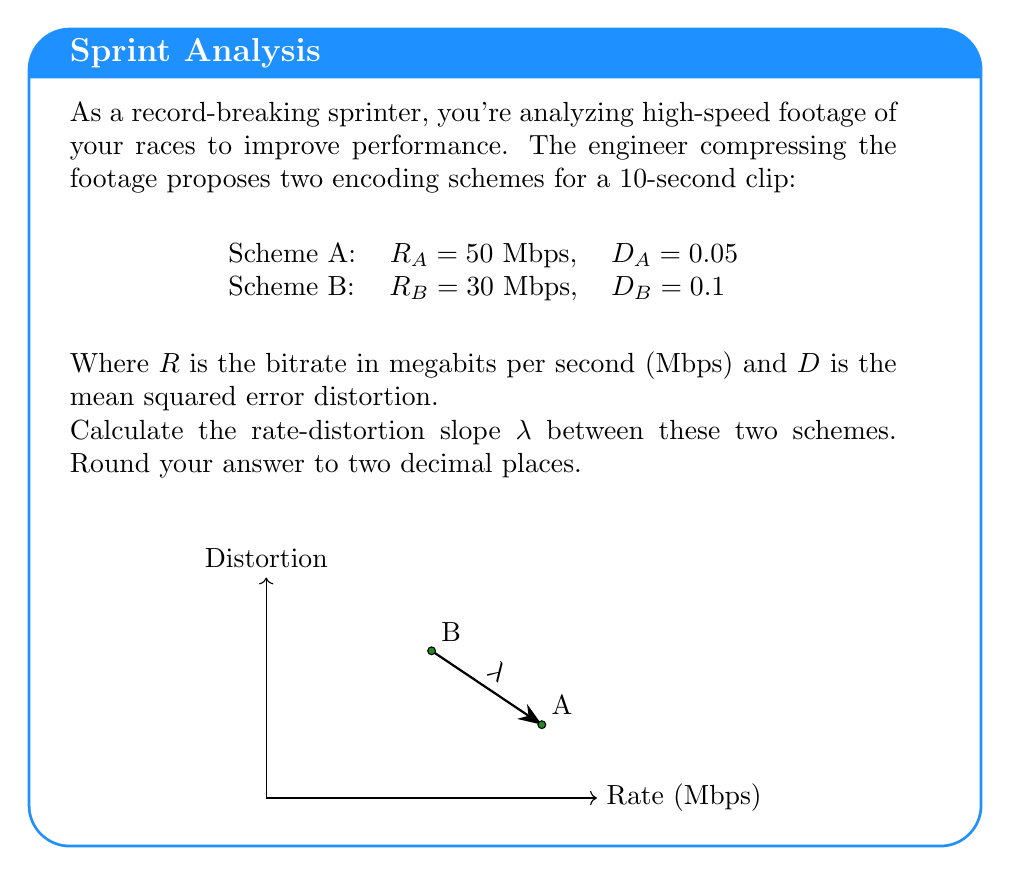What is the answer to this math problem? To solve this problem, we need to calculate the rate-distortion slope $\lambda$ between schemes A and B. The rate-distortion slope represents the trade-off between the reduction in distortion and the increase in bitrate.

The formula for the rate-distortion slope is:

$$\lambda = -\frac{\Delta D}{\Delta R}$$

Where:
$\Delta D$ is the change in distortion
$\Delta R$ is the change in rate

Step 1: Calculate $\Delta D$
$\Delta D = D_A - D_B = 0.05 - 0.1 = -0.05$

Step 2: Calculate $\Delta R$
$\Delta R = R_A - R_B = 50 - 30 = 20$ Mbps

Step 3: Calculate $\lambda$
$$\lambda = -\frac{\Delta D}{\Delta R} = -\frac{-0.05}{20} = \frac{0.05}{20} = 0.0025$$

Step 4: Round to two decimal places
$0.0025$ rounded to two decimal places is $0.00$

The rate-distortion slope $\lambda$ is 0.00, which indicates that there is a very small improvement in distortion for a large increase in bitrate between these two schemes.
Answer: $\lambda = 0.00$ 